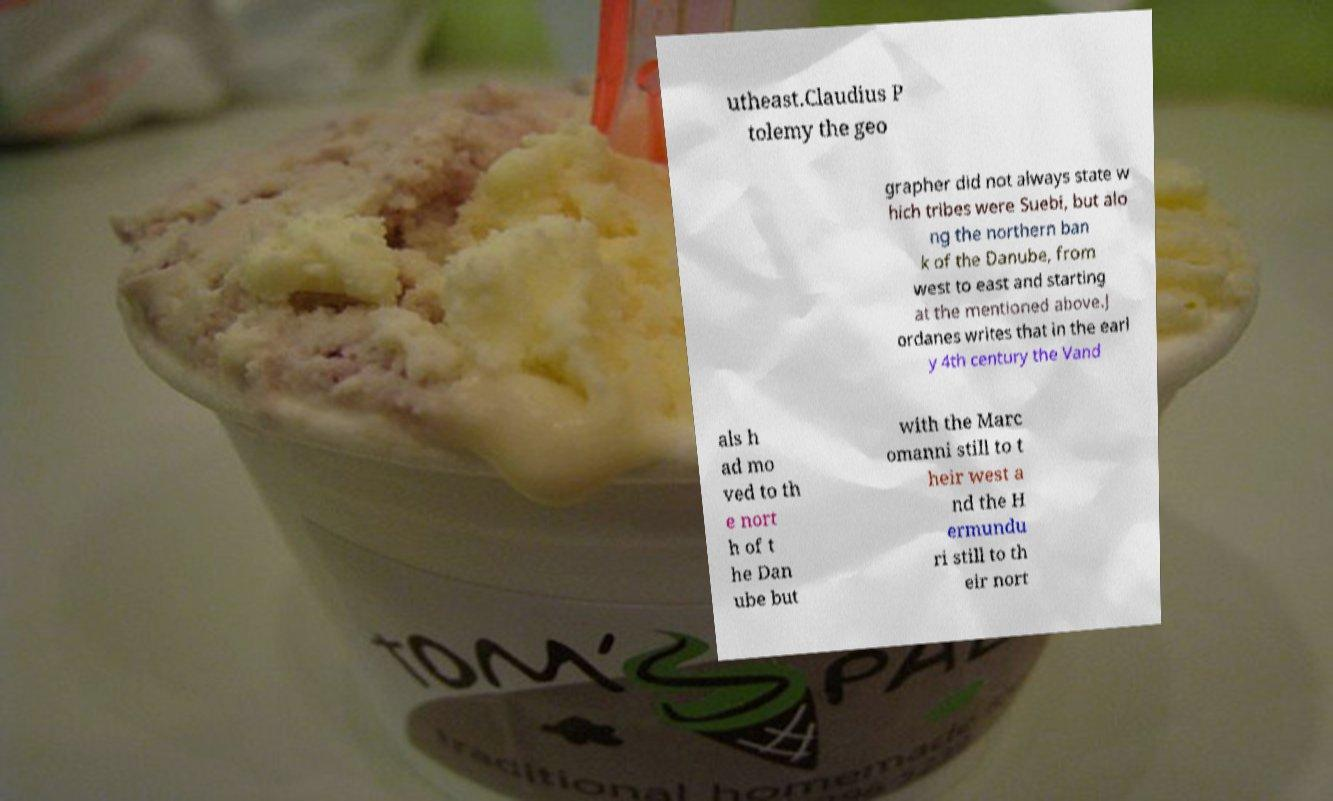Please identify and transcribe the text found in this image. utheast.Claudius P tolemy the geo grapher did not always state w hich tribes were Suebi, but alo ng the northern ban k of the Danube, from west to east and starting at the mentioned above.J ordanes writes that in the earl y 4th century the Vand als h ad mo ved to th e nort h of t he Dan ube but with the Marc omanni still to t heir west a nd the H ermundu ri still to th eir nort 